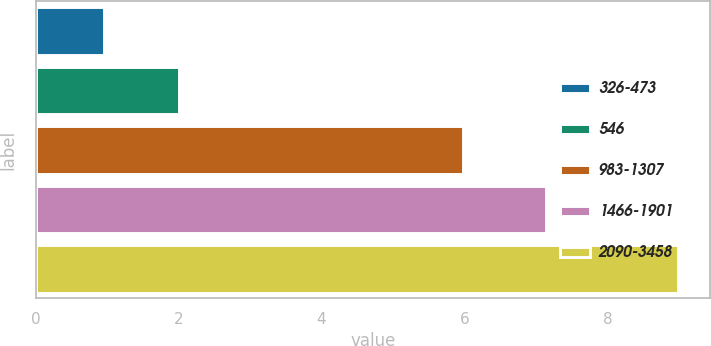Convert chart to OTSL. <chart><loc_0><loc_0><loc_500><loc_500><bar_chart><fcel>326-473<fcel>546<fcel>983-1307<fcel>1466-1901<fcel>2090-3458<nl><fcel>0.95<fcel>2<fcel>5.98<fcel>7.14<fcel>8.99<nl></chart> 